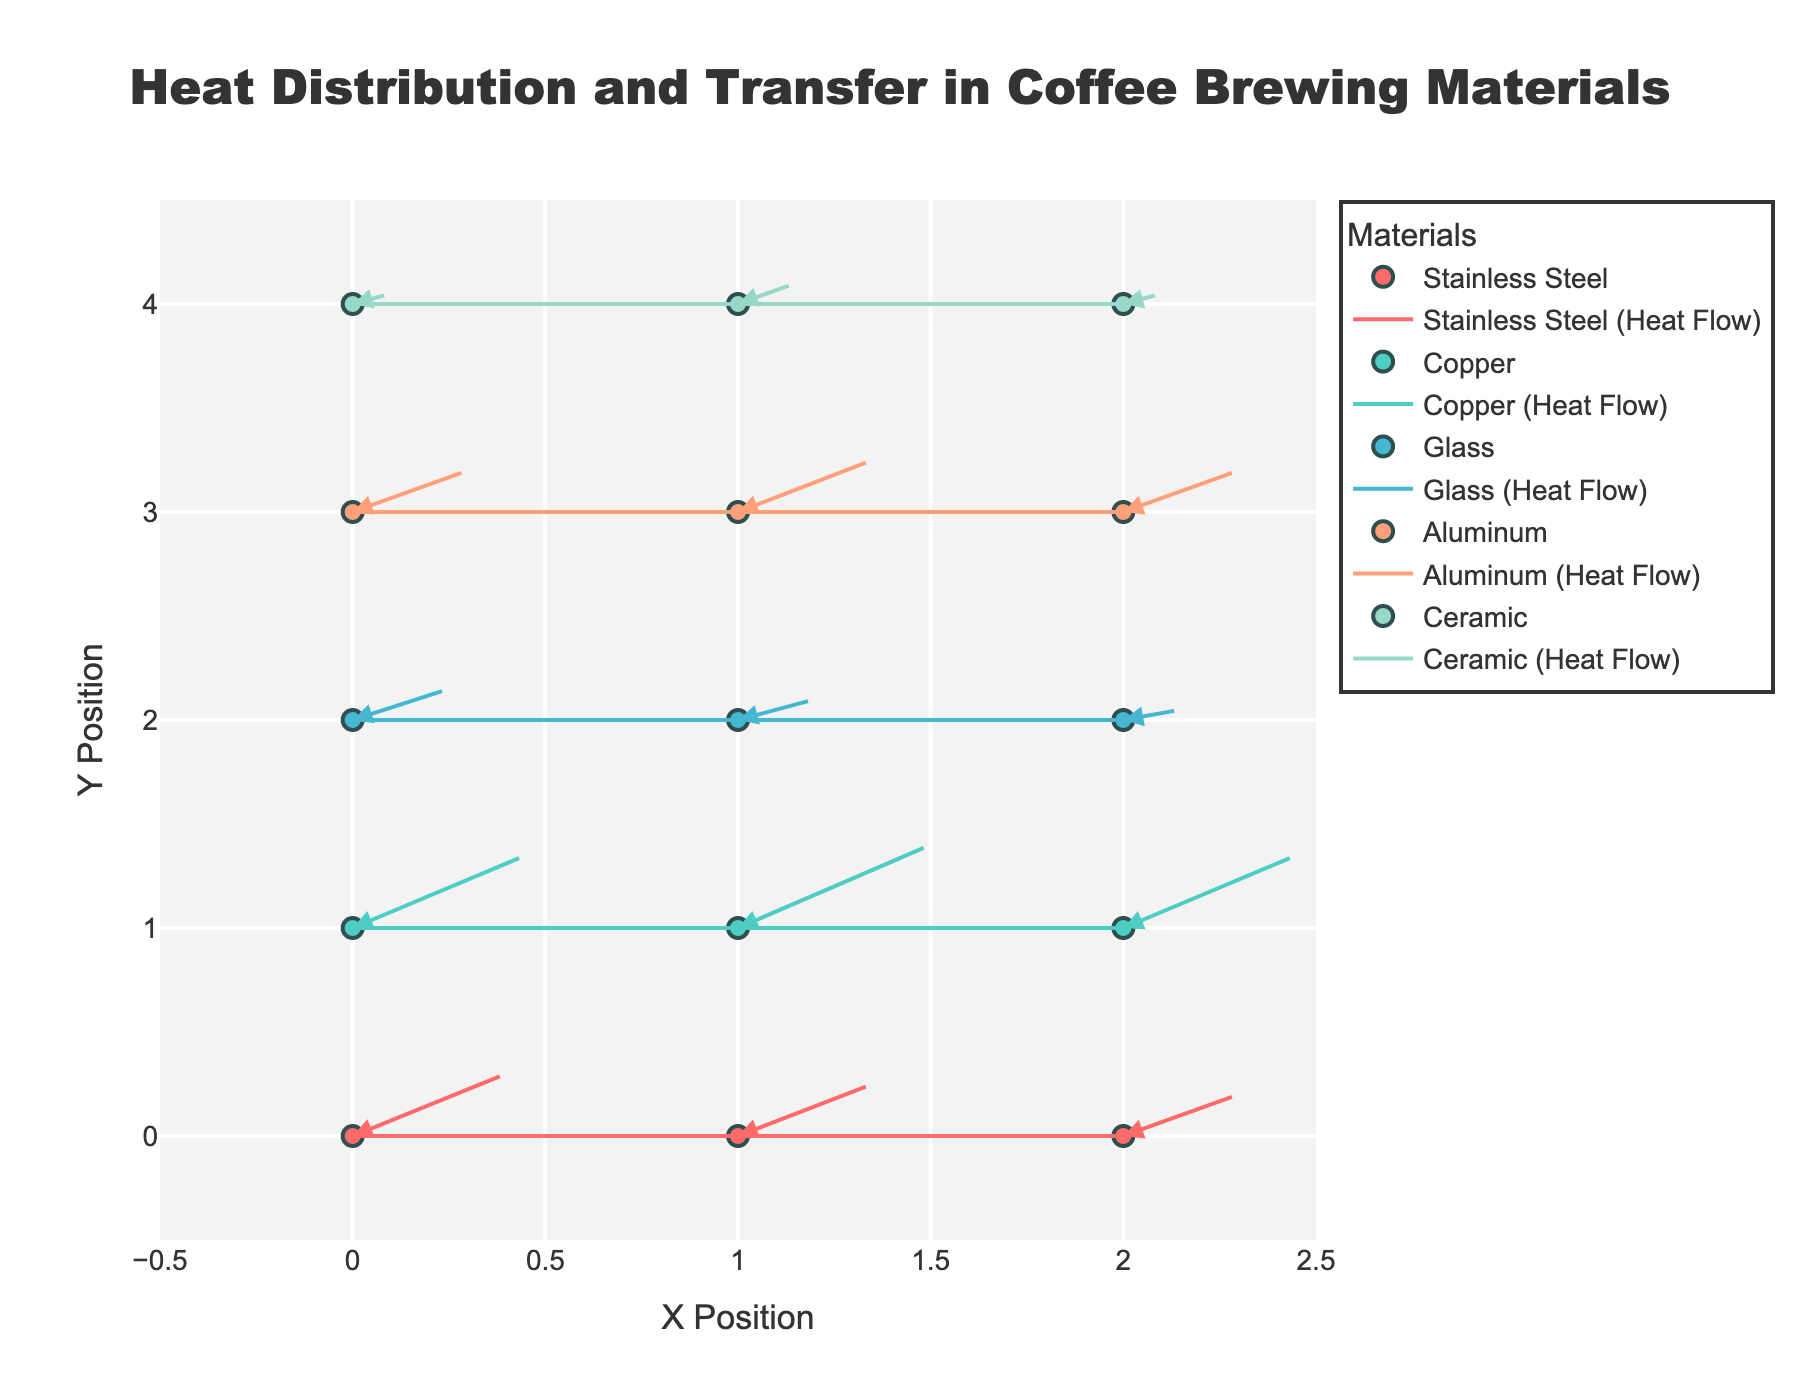What materials are being compared in the figure? The figure includes five materials: Stainless Steel, Copper, Glass, Aluminum, and Ceramic. These are listed explicitly in the legend.
Answer: Stainless Steel, Copper, Glass, Aluminum, Ceramic Which material shows the highest heat transfer vector magnitude at position (0, 1)? The highest heat transfer vector at position (0, 1) is for Copper with a vector magnitude of (0.9, 0.7). The vector's length can be calculated as sqrt(0.9^2 + 0.7^2), which is clearly longer than others at that position.
Answer: Copper How many data points are there for each material? By counting the markers and arrows in the figure, each material has three data points plotted. This can be inferred by observing the x and y positions labeled for each material.
Answer: 3 Which material exhibits the smallest heat transfer vector magnitude overall, and at what position? Glass at position (2, 2) shows the smallest vector magnitude with (0.3, 0.1). The vector magnitude is sqrt(0.3^2 + 0.1^2), which is the smallest compared to other vectors.
Answer: Glass at position (2, 2) How does the heat transfer vector for Aluminum at position (1, 3) compare to Copper at position (1, 1)? Aluminum at (1, 3) has a vector of (0.7, 0.5) with a magnitude of sqrt(0.7^2 + 0.5^2). Copper at (1, 1) has a vector of (1.0, 0.8) with a magnitude of sqrt(1.0^2 + 0.8^2). Therefore, the heat transfer for Copper is significantly greater.
Answer: Copper's heat transfer vector is greater Which material has the largest heat transfer variation across its data points? Copper has the largest range in its vector components (1.0, 0.8) to (0.9, 0.7), compared to other materials whose vector components are less varied.
Answer: Copper What is the average heat transfer vector magnitude for Stainless Steel? Calculate the magnitudes for Stainless Steel at its three points: sqrt(0.8^2 + 0.6^2), sqrt(0.7^2 + 0.5^2), and sqrt(0.6^2 + 0.4^2) and then find the average. The values are approximately 1.0, 0.86, and 0.72. The average of these values is approximately (1.0 + 0.86 + 0.72) / 3.
Answer: Approximately 0.86 At which position does Ceramic show the smallest heat transfer vector, and what is the magnitude? Ceramic at (2, 4) shows the smallest heat transfer vector with (0.2, 0.1). The magnitude is sqrt(0.2^2 + 0.1^2).
Answer: (2, 4) with a magnitude of approximately 0.22 Identify two materials which have the most similar heat transfer vectors at any given position. At position (2, 0) Stainless Steel has a vector (0.6, 0.4) and at (2, 3) Aluminum also has a vector (0.6, 0.4), making them the most similar in terms of vector direction and magnitude.
Answer: Stainless Steel and Aluminum 